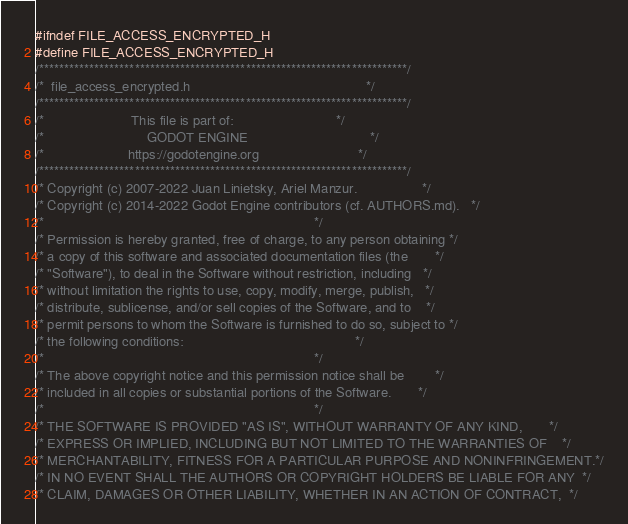<code> <loc_0><loc_0><loc_500><loc_500><_C_>#ifndef FILE_ACCESS_ENCRYPTED_H
#define FILE_ACCESS_ENCRYPTED_H
/*************************************************************************/
/*  file_access_encrypted.h                                              */
/*************************************************************************/
/*                       This file is part of:                           */
/*                           GODOT ENGINE                                */
/*                      https://godotengine.org                          */
/*************************************************************************/
/* Copyright (c) 2007-2022 Juan Linietsky, Ariel Manzur.                 */
/* Copyright (c) 2014-2022 Godot Engine contributors (cf. AUTHORS.md).   */
/*                                                                       */
/* Permission is hereby granted, free of charge, to any person obtaining */
/* a copy of this software and associated documentation files (the       */
/* "Software"), to deal in the Software without restriction, including   */
/* without limitation the rights to use, copy, modify, merge, publish,   */
/* distribute, sublicense, and/or sell copies of the Software, and to    */
/* permit persons to whom the Software is furnished to do so, subject to */
/* the following conditions:                                             */
/*                                                                       */
/* The above copyright notice and this permission notice shall be        */
/* included in all copies or substantial portions of the Software.       */
/*                                                                       */
/* THE SOFTWARE IS PROVIDED "AS IS", WITHOUT WARRANTY OF ANY KIND,       */
/* EXPRESS OR IMPLIED, INCLUDING BUT NOT LIMITED TO THE WARRANTIES OF    */
/* MERCHANTABILITY, FITNESS FOR A PARTICULAR PURPOSE AND NONINFRINGEMENT.*/
/* IN NO EVENT SHALL THE AUTHORS OR COPYRIGHT HOLDERS BE LIABLE FOR ANY  */
/* CLAIM, DAMAGES OR OTHER LIABILITY, WHETHER IN AN ACTION OF CONTRACT,  */</code> 